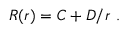<formula> <loc_0><loc_0><loc_500><loc_500>R ( r ) = C + D / r \ .</formula> 